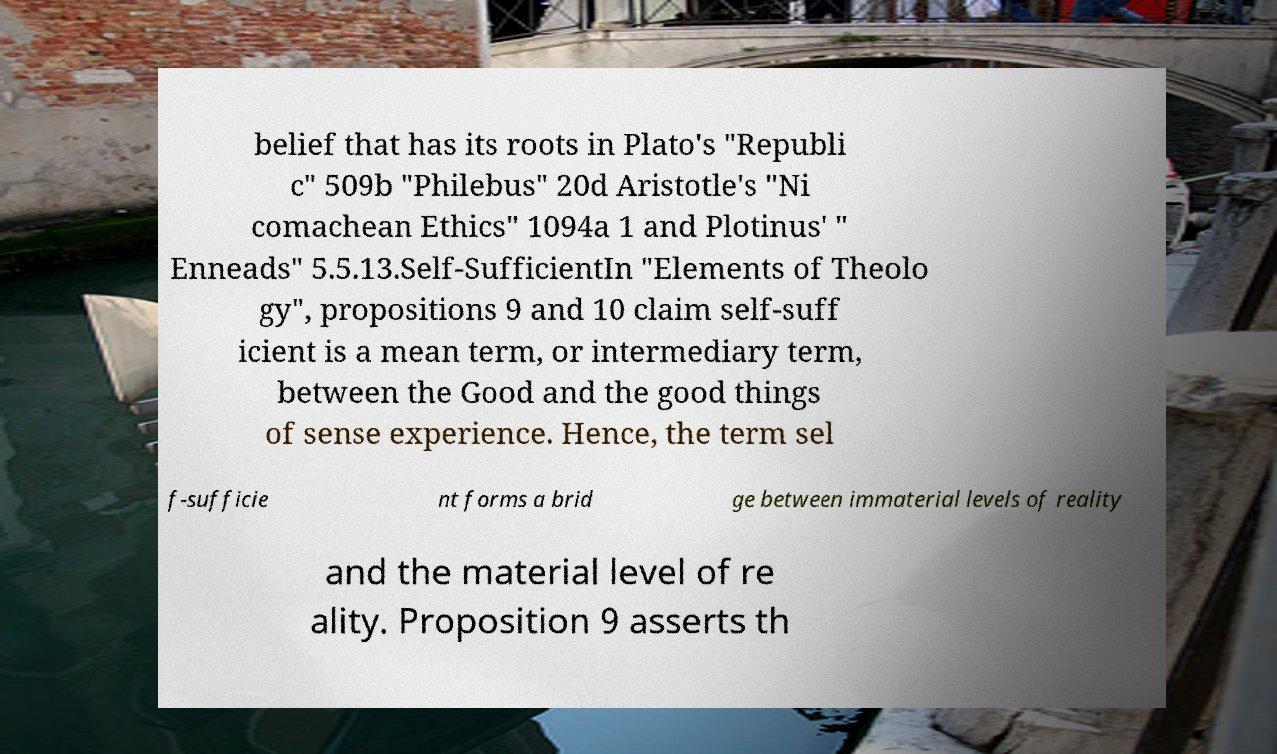Could you extract and type out the text from this image? belief that has its roots in Plato's "Republi c" 509b "Philebus" 20d Aristotle's "Ni comachean Ethics" 1094a 1 and Plotinus' " Enneads" 5.5.13.Self-SufficientIn "Elements of Theolo gy", propositions 9 and 10 claim self-suff icient is a mean term, or intermediary term, between the Good and the good things of sense experience. Hence, the term sel f-sufficie nt forms a brid ge between immaterial levels of reality and the material level of re ality. Proposition 9 asserts th 